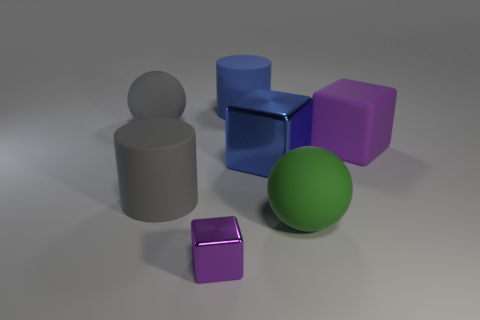Add 1 red shiny balls. How many objects exist? 8 Subtract all purple blocks. How many blocks are left? 1 Subtract all red balls. Subtract all brown cylinders. How many balls are left? 2 Subtract all purple cylinders. How many green spheres are left? 1 Subtract all blue objects. Subtract all big spheres. How many objects are left? 3 Add 1 blue cylinders. How many blue cylinders are left? 2 Add 3 rubber cylinders. How many rubber cylinders exist? 5 Subtract all blue cylinders. How many cylinders are left? 1 Subtract 0 yellow cylinders. How many objects are left? 7 Subtract all spheres. How many objects are left? 5 